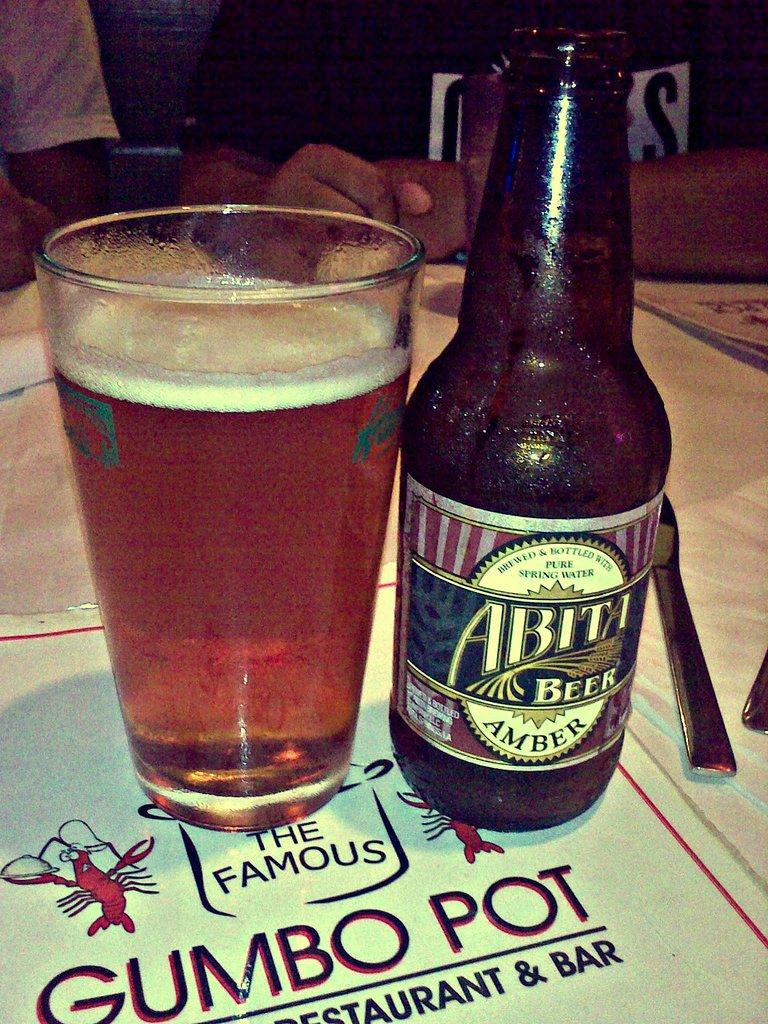<image>
Give a short and clear explanation of the subsequent image. A bottle of Abita beer and a glass beside it. 